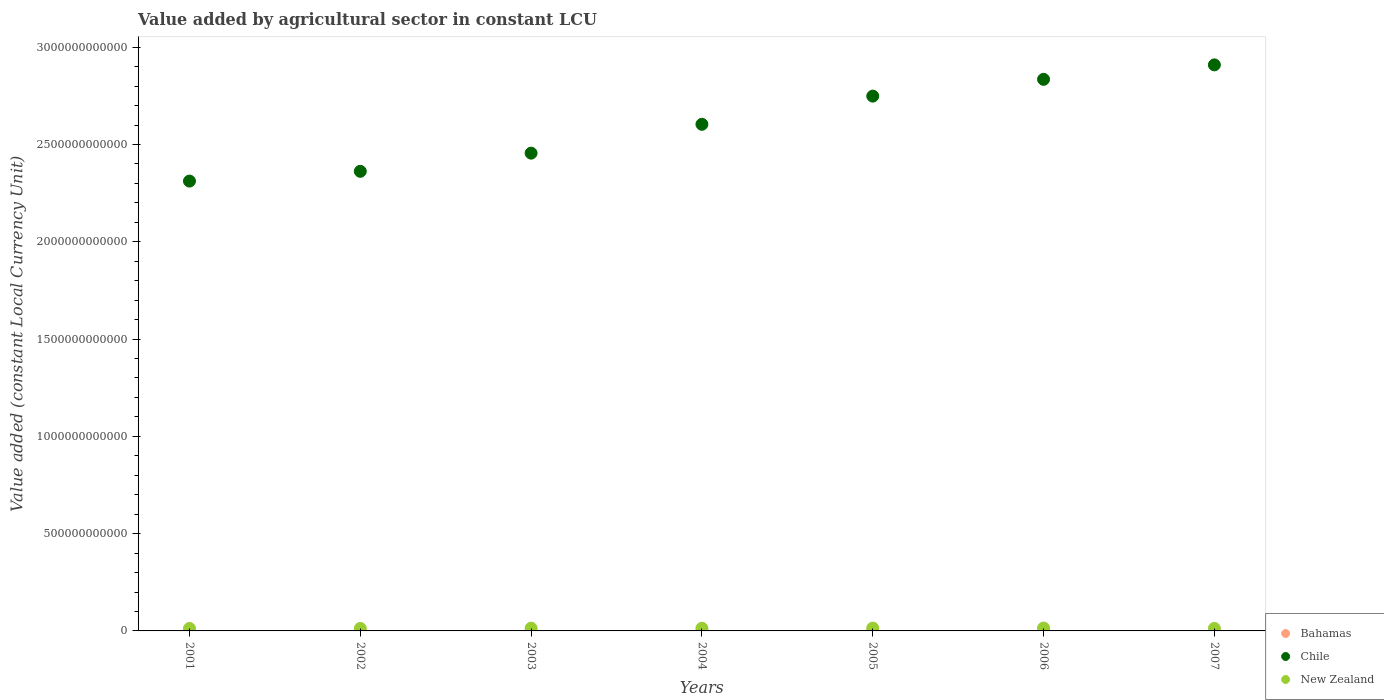Is the number of dotlines equal to the number of legend labels?
Keep it short and to the point. Yes. What is the value added by agricultural sector in New Zealand in 2003?
Offer a very short reply. 1.43e+1. Across all years, what is the maximum value added by agricultural sector in Bahamas?
Your answer should be very brief. 2.34e+08. Across all years, what is the minimum value added by agricultural sector in Chile?
Your answer should be compact. 2.31e+12. What is the total value added by agricultural sector in Bahamas in the graph?
Give a very brief answer. 1.40e+09. What is the difference between the value added by agricultural sector in New Zealand in 2002 and that in 2005?
Offer a terse response. -1.72e+09. What is the difference between the value added by agricultural sector in Bahamas in 2003 and the value added by agricultural sector in New Zealand in 2001?
Offer a very short reply. -1.27e+1. What is the average value added by agricultural sector in New Zealand per year?
Make the answer very short. 1.37e+1. In the year 2007, what is the difference between the value added by agricultural sector in New Zealand and value added by agricultural sector in Chile?
Offer a very short reply. -2.90e+12. In how many years, is the value added by agricultural sector in Chile greater than 600000000000 LCU?
Give a very brief answer. 7. What is the ratio of the value added by agricultural sector in Chile in 2003 to that in 2005?
Your answer should be compact. 0.89. Is the difference between the value added by agricultural sector in New Zealand in 2004 and 2005 greater than the difference between the value added by agricultural sector in Chile in 2004 and 2005?
Your answer should be very brief. Yes. What is the difference between the highest and the second highest value added by agricultural sector in Chile?
Offer a very short reply. 7.42e+1. What is the difference between the highest and the lowest value added by agricultural sector in Chile?
Make the answer very short. 5.97e+11. Is the sum of the value added by agricultural sector in Chile in 2003 and 2004 greater than the maximum value added by agricultural sector in New Zealand across all years?
Ensure brevity in your answer.  Yes. Is it the case that in every year, the sum of the value added by agricultural sector in Bahamas and value added by agricultural sector in New Zealand  is greater than the value added by agricultural sector in Chile?
Your answer should be very brief. No. Does the value added by agricultural sector in Bahamas monotonically increase over the years?
Your response must be concise. No. How many dotlines are there?
Provide a short and direct response. 3. What is the difference between two consecutive major ticks on the Y-axis?
Provide a succinct answer. 5.00e+11. Does the graph contain any zero values?
Your answer should be very brief. No. Does the graph contain grids?
Make the answer very short. No. How many legend labels are there?
Provide a succinct answer. 3. How are the legend labels stacked?
Ensure brevity in your answer.  Vertical. What is the title of the graph?
Your response must be concise. Value added by agricultural sector in constant LCU. What is the label or title of the X-axis?
Offer a terse response. Years. What is the label or title of the Y-axis?
Ensure brevity in your answer.  Value added (constant Local Currency Unit). What is the Value added (constant Local Currency Unit) of Bahamas in 2001?
Give a very brief answer. 1.89e+08. What is the Value added (constant Local Currency Unit) of Chile in 2001?
Provide a short and direct response. 2.31e+12. What is the Value added (constant Local Currency Unit) in New Zealand in 2001?
Your response must be concise. 1.29e+1. What is the Value added (constant Local Currency Unit) in Bahamas in 2002?
Your answer should be compact. 2.15e+08. What is the Value added (constant Local Currency Unit) of Chile in 2002?
Your answer should be compact. 2.36e+12. What is the Value added (constant Local Currency Unit) of New Zealand in 2002?
Your answer should be compact. 1.28e+1. What is the Value added (constant Local Currency Unit) of Bahamas in 2003?
Give a very brief answer. 2.34e+08. What is the Value added (constant Local Currency Unit) in Chile in 2003?
Your response must be concise. 2.46e+12. What is the Value added (constant Local Currency Unit) of New Zealand in 2003?
Provide a succinct answer. 1.43e+1. What is the Value added (constant Local Currency Unit) in Bahamas in 2004?
Give a very brief answer. 2.18e+08. What is the Value added (constant Local Currency Unit) of Chile in 2004?
Your answer should be compact. 2.60e+12. What is the Value added (constant Local Currency Unit) of New Zealand in 2004?
Your response must be concise. 1.38e+1. What is the Value added (constant Local Currency Unit) of Bahamas in 2005?
Make the answer very short. 1.97e+08. What is the Value added (constant Local Currency Unit) in Chile in 2005?
Your answer should be very brief. 2.75e+12. What is the Value added (constant Local Currency Unit) in New Zealand in 2005?
Provide a short and direct response. 1.46e+1. What is the Value added (constant Local Currency Unit) in Bahamas in 2006?
Provide a succinct answer. 1.80e+08. What is the Value added (constant Local Currency Unit) in Chile in 2006?
Offer a terse response. 2.83e+12. What is the Value added (constant Local Currency Unit) in New Zealand in 2006?
Provide a succinct answer. 1.48e+1. What is the Value added (constant Local Currency Unit) in Bahamas in 2007?
Your response must be concise. 1.67e+08. What is the Value added (constant Local Currency Unit) in Chile in 2007?
Your answer should be very brief. 2.91e+12. What is the Value added (constant Local Currency Unit) of New Zealand in 2007?
Provide a succinct answer. 1.30e+1. Across all years, what is the maximum Value added (constant Local Currency Unit) in Bahamas?
Offer a very short reply. 2.34e+08. Across all years, what is the maximum Value added (constant Local Currency Unit) of Chile?
Offer a terse response. 2.91e+12. Across all years, what is the maximum Value added (constant Local Currency Unit) in New Zealand?
Offer a terse response. 1.48e+1. Across all years, what is the minimum Value added (constant Local Currency Unit) in Bahamas?
Provide a succinct answer. 1.67e+08. Across all years, what is the minimum Value added (constant Local Currency Unit) in Chile?
Provide a succinct answer. 2.31e+12. Across all years, what is the minimum Value added (constant Local Currency Unit) in New Zealand?
Provide a succinct answer. 1.28e+1. What is the total Value added (constant Local Currency Unit) in Bahamas in the graph?
Give a very brief answer. 1.40e+09. What is the total Value added (constant Local Currency Unit) in Chile in the graph?
Your answer should be very brief. 1.82e+13. What is the total Value added (constant Local Currency Unit) of New Zealand in the graph?
Provide a succinct answer. 9.61e+1. What is the difference between the Value added (constant Local Currency Unit) in Bahamas in 2001 and that in 2002?
Keep it short and to the point. -2.56e+07. What is the difference between the Value added (constant Local Currency Unit) in Chile in 2001 and that in 2002?
Your answer should be very brief. -5.01e+1. What is the difference between the Value added (constant Local Currency Unit) of New Zealand in 2001 and that in 2002?
Make the answer very short. 7.30e+07. What is the difference between the Value added (constant Local Currency Unit) of Bahamas in 2001 and that in 2003?
Your answer should be compact. -4.52e+07. What is the difference between the Value added (constant Local Currency Unit) of Chile in 2001 and that in 2003?
Make the answer very short. -1.44e+11. What is the difference between the Value added (constant Local Currency Unit) of New Zealand in 2001 and that in 2003?
Ensure brevity in your answer.  -1.37e+09. What is the difference between the Value added (constant Local Currency Unit) in Bahamas in 2001 and that in 2004?
Provide a short and direct response. -2.93e+07. What is the difference between the Value added (constant Local Currency Unit) in Chile in 2001 and that in 2004?
Your answer should be compact. -2.92e+11. What is the difference between the Value added (constant Local Currency Unit) of New Zealand in 2001 and that in 2004?
Provide a succinct answer. -9.27e+08. What is the difference between the Value added (constant Local Currency Unit) in Bahamas in 2001 and that in 2005?
Offer a terse response. -7.60e+06. What is the difference between the Value added (constant Local Currency Unit) of Chile in 2001 and that in 2005?
Provide a short and direct response. -4.37e+11. What is the difference between the Value added (constant Local Currency Unit) of New Zealand in 2001 and that in 2005?
Your response must be concise. -1.65e+09. What is the difference between the Value added (constant Local Currency Unit) in Bahamas in 2001 and that in 2006?
Ensure brevity in your answer.  8.47e+06. What is the difference between the Value added (constant Local Currency Unit) in Chile in 2001 and that in 2006?
Your response must be concise. -5.23e+11. What is the difference between the Value added (constant Local Currency Unit) in New Zealand in 2001 and that in 2006?
Offer a very short reply. -1.86e+09. What is the difference between the Value added (constant Local Currency Unit) of Bahamas in 2001 and that in 2007?
Your answer should be very brief. 2.17e+07. What is the difference between the Value added (constant Local Currency Unit) of Chile in 2001 and that in 2007?
Provide a succinct answer. -5.97e+11. What is the difference between the Value added (constant Local Currency Unit) in New Zealand in 2001 and that in 2007?
Give a very brief answer. -4.23e+07. What is the difference between the Value added (constant Local Currency Unit) in Bahamas in 2002 and that in 2003?
Provide a succinct answer. -1.96e+07. What is the difference between the Value added (constant Local Currency Unit) in Chile in 2002 and that in 2003?
Offer a terse response. -9.35e+1. What is the difference between the Value added (constant Local Currency Unit) in New Zealand in 2002 and that in 2003?
Give a very brief answer. -1.44e+09. What is the difference between the Value added (constant Local Currency Unit) in Bahamas in 2002 and that in 2004?
Your response must be concise. -3.66e+06. What is the difference between the Value added (constant Local Currency Unit) of Chile in 2002 and that in 2004?
Offer a terse response. -2.42e+11. What is the difference between the Value added (constant Local Currency Unit) in New Zealand in 2002 and that in 2004?
Your response must be concise. -1.00e+09. What is the difference between the Value added (constant Local Currency Unit) of Bahamas in 2002 and that in 2005?
Offer a very short reply. 1.80e+07. What is the difference between the Value added (constant Local Currency Unit) of Chile in 2002 and that in 2005?
Give a very brief answer. -3.87e+11. What is the difference between the Value added (constant Local Currency Unit) of New Zealand in 2002 and that in 2005?
Keep it short and to the point. -1.72e+09. What is the difference between the Value added (constant Local Currency Unit) of Bahamas in 2002 and that in 2006?
Ensure brevity in your answer.  3.41e+07. What is the difference between the Value added (constant Local Currency Unit) of Chile in 2002 and that in 2006?
Provide a succinct answer. -4.73e+11. What is the difference between the Value added (constant Local Currency Unit) of New Zealand in 2002 and that in 2006?
Offer a very short reply. -1.93e+09. What is the difference between the Value added (constant Local Currency Unit) in Bahamas in 2002 and that in 2007?
Keep it short and to the point. 4.73e+07. What is the difference between the Value added (constant Local Currency Unit) in Chile in 2002 and that in 2007?
Your response must be concise. -5.47e+11. What is the difference between the Value added (constant Local Currency Unit) in New Zealand in 2002 and that in 2007?
Your answer should be very brief. -1.15e+08. What is the difference between the Value added (constant Local Currency Unit) of Bahamas in 2003 and that in 2004?
Provide a succinct answer. 1.60e+07. What is the difference between the Value added (constant Local Currency Unit) of Chile in 2003 and that in 2004?
Provide a succinct answer. -1.48e+11. What is the difference between the Value added (constant Local Currency Unit) in New Zealand in 2003 and that in 2004?
Give a very brief answer. 4.39e+08. What is the difference between the Value added (constant Local Currency Unit) of Bahamas in 2003 and that in 2005?
Provide a succinct answer. 3.76e+07. What is the difference between the Value added (constant Local Currency Unit) of Chile in 2003 and that in 2005?
Make the answer very short. -2.93e+11. What is the difference between the Value added (constant Local Currency Unit) of New Zealand in 2003 and that in 2005?
Provide a short and direct response. -2.79e+08. What is the difference between the Value added (constant Local Currency Unit) of Bahamas in 2003 and that in 2006?
Provide a short and direct response. 5.37e+07. What is the difference between the Value added (constant Local Currency Unit) of Chile in 2003 and that in 2006?
Ensure brevity in your answer.  -3.79e+11. What is the difference between the Value added (constant Local Currency Unit) in New Zealand in 2003 and that in 2006?
Your response must be concise. -4.94e+08. What is the difference between the Value added (constant Local Currency Unit) in Bahamas in 2003 and that in 2007?
Make the answer very short. 6.69e+07. What is the difference between the Value added (constant Local Currency Unit) of Chile in 2003 and that in 2007?
Offer a terse response. -4.54e+11. What is the difference between the Value added (constant Local Currency Unit) in New Zealand in 2003 and that in 2007?
Ensure brevity in your answer.  1.32e+09. What is the difference between the Value added (constant Local Currency Unit) of Bahamas in 2004 and that in 2005?
Your answer should be compact. 2.17e+07. What is the difference between the Value added (constant Local Currency Unit) of Chile in 2004 and that in 2005?
Your answer should be compact. -1.45e+11. What is the difference between the Value added (constant Local Currency Unit) of New Zealand in 2004 and that in 2005?
Give a very brief answer. -7.18e+08. What is the difference between the Value added (constant Local Currency Unit) of Bahamas in 2004 and that in 2006?
Keep it short and to the point. 3.77e+07. What is the difference between the Value added (constant Local Currency Unit) of Chile in 2004 and that in 2006?
Provide a short and direct response. -2.31e+11. What is the difference between the Value added (constant Local Currency Unit) in New Zealand in 2004 and that in 2006?
Your answer should be very brief. -9.34e+08. What is the difference between the Value added (constant Local Currency Unit) of Bahamas in 2004 and that in 2007?
Give a very brief answer. 5.10e+07. What is the difference between the Value added (constant Local Currency Unit) of Chile in 2004 and that in 2007?
Your response must be concise. -3.05e+11. What is the difference between the Value added (constant Local Currency Unit) of New Zealand in 2004 and that in 2007?
Your answer should be very brief. 8.85e+08. What is the difference between the Value added (constant Local Currency Unit) in Bahamas in 2005 and that in 2006?
Offer a very short reply. 1.61e+07. What is the difference between the Value added (constant Local Currency Unit) in Chile in 2005 and that in 2006?
Your answer should be very brief. -8.64e+1. What is the difference between the Value added (constant Local Currency Unit) of New Zealand in 2005 and that in 2006?
Your response must be concise. -2.15e+08. What is the difference between the Value added (constant Local Currency Unit) in Bahamas in 2005 and that in 2007?
Ensure brevity in your answer.  2.93e+07. What is the difference between the Value added (constant Local Currency Unit) of Chile in 2005 and that in 2007?
Offer a very short reply. -1.61e+11. What is the difference between the Value added (constant Local Currency Unit) in New Zealand in 2005 and that in 2007?
Your response must be concise. 1.60e+09. What is the difference between the Value added (constant Local Currency Unit) in Bahamas in 2006 and that in 2007?
Your answer should be compact. 1.32e+07. What is the difference between the Value added (constant Local Currency Unit) of Chile in 2006 and that in 2007?
Your answer should be very brief. -7.42e+1. What is the difference between the Value added (constant Local Currency Unit) in New Zealand in 2006 and that in 2007?
Offer a terse response. 1.82e+09. What is the difference between the Value added (constant Local Currency Unit) of Bahamas in 2001 and the Value added (constant Local Currency Unit) of Chile in 2002?
Your response must be concise. -2.36e+12. What is the difference between the Value added (constant Local Currency Unit) in Bahamas in 2001 and the Value added (constant Local Currency Unit) in New Zealand in 2002?
Give a very brief answer. -1.26e+1. What is the difference between the Value added (constant Local Currency Unit) of Chile in 2001 and the Value added (constant Local Currency Unit) of New Zealand in 2002?
Ensure brevity in your answer.  2.30e+12. What is the difference between the Value added (constant Local Currency Unit) in Bahamas in 2001 and the Value added (constant Local Currency Unit) in Chile in 2003?
Provide a succinct answer. -2.46e+12. What is the difference between the Value added (constant Local Currency Unit) of Bahamas in 2001 and the Value added (constant Local Currency Unit) of New Zealand in 2003?
Provide a short and direct response. -1.41e+1. What is the difference between the Value added (constant Local Currency Unit) in Chile in 2001 and the Value added (constant Local Currency Unit) in New Zealand in 2003?
Give a very brief answer. 2.30e+12. What is the difference between the Value added (constant Local Currency Unit) in Bahamas in 2001 and the Value added (constant Local Currency Unit) in Chile in 2004?
Offer a very short reply. -2.60e+12. What is the difference between the Value added (constant Local Currency Unit) in Bahamas in 2001 and the Value added (constant Local Currency Unit) in New Zealand in 2004?
Your answer should be compact. -1.36e+1. What is the difference between the Value added (constant Local Currency Unit) in Chile in 2001 and the Value added (constant Local Currency Unit) in New Zealand in 2004?
Provide a short and direct response. 2.30e+12. What is the difference between the Value added (constant Local Currency Unit) of Bahamas in 2001 and the Value added (constant Local Currency Unit) of Chile in 2005?
Your response must be concise. -2.75e+12. What is the difference between the Value added (constant Local Currency Unit) of Bahamas in 2001 and the Value added (constant Local Currency Unit) of New Zealand in 2005?
Ensure brevity in your answer.  -1.44e+1. What is the difference between the Value added (constant Local Currency Unit) in Chile in 2001 and the Value added (constant Local Currency Unit) in New Zealand in 2005?
Offer a terse response. 2.30e+12. What is the difference between the Value added (constant Local Currency Unit) of Bahamas in 2001 and the Value added (constant Local Currency Unit) of Chile in 2006?
Your answer should be compact. -2.83e+12. What is the difference between the Value added (constant Local Currency Unit) of Bahamas in 2001 and the Value added (constant Local Currency Unit) of New Zealand in 2006?
Your response must be concise. -1.46e+1. What is the difference between the Value added (constant Local Currency Unit) in Chile in 2001 and the Value added (constant Local Currency Unit) in New Zealand in 2006?
Give a very brief answer. 2.30e+12. What is the difference between the Value added (constant Local Currency Unit) of Bahamas in 2001 and the Value added (constant Local Currency Unit) of Chile in 2007?
Make the answer very short. -2.91e+12. What is the difference between the Value added (constant Local Currency Unit) in Bahamas in 2001 and the Value added (constant Local Currency Unit) in New Zealand in 2007?
Make the answer very short. -1.28e+1. What is the difference between the Value added (constant Local Currency Unit) in Chile in 2001 and the Value added (constant Local Currency Unit) in New Zealand in 2007?
Provide a succinct answer. 2.30e+12. What is the difference between the Value added (constant Local Currency Unit) in Bahamas in 2002 and the Value added (constant Local Currency Unit) in Chile in 2003?
Provide a short and direct response. -2.46e+12. What is the difference between the Value added (constant Local Currency Unit) of Bahamas in 2002 and the Value added (constant Local Currency Unit) of New Zealand in 2003?
Give a very brief answer. -1.41e+1. What is the difference between the Value added (constant Local Currency Unit) in Chile in 2002 and the Value added (constant Local Currency Unit) in New Zealand in 2003?
Your answer should be very brief. 2.35e+12. What is the difference between the Value added (constant Local Currency Unit) in Bahamas in 2002 and the Value added (constant Local Currency Unit) in Chile in 2004?
Provide a succinct answer. -2.60e+12. What is the difference between the Value added (constant Local Currency Unit) in Bahamas in 2002 and the Value added (constant Local Currency Unit) in New Zealand in 2004?
Your answer should be very brief. -1.36e+1. What is the difference between the Value added (constant Local Currency Unit) of Chile in 2002 and the Value added (constant Local Currency Unit) of New Zealand in 2004?
Offer a terse response. 2.35e+12. What is the difference between the Value added (constant Local Currency Unit) of Bahamas in 2002 and the Value added (constant Local Currency Unit) of Chile in 2005?
Your answer should be very brief. -2.75e+12. What is the difference between the Value added (constant Local Currency Unit) in Bahamas in 2002 and the Value added (constant Local Currency Unit) in New Zealand in 2005?
Your answer should be very brief. -1.43e+1. What is the difference between the Value added (constant Local Currency Unit) of Chile in 2002 and the Value added (constant Local Currency Unit) of New Zealand in 2005?
Provide a short and direct response. 2.35e+12. What is the difference between the Value added (constant Local Currency Unit) of Bahamas in 2002 and the Value added (constant Local Currency Unit) of Chile in 2006?
Your answer should be compact. -2.83e+12. What is the difference between the Value added (constant Local Currency Unit) in Bahamas in 2002 and the Value added (constant Local Currency Unit) in New Zealand in 2006?
Your answer should be very brief. -1.46e+1. What is the difference between the Value added (constant Local Currency Unit) of Chile in 2002 and the Value added (constant Local Currency Unit) of New Zealand in 2006?
Offer a terse response. 2.35e+12. What is the difference between the Value added (constant Local Currency Unit) in Bahamas in 2002 and the Value added (constant Local Currency Unit) in Chile in 2007?
Give a very brief answer. -2.91e+12. What is the difference between the Value added (constant Local Currency Unit) in Bahamas in 2002 and the Value added (constant Local Currency Unit) in New Zealand in 2007?
Offer a very short reply. -1.27e+1. What is the difference between the Value added (constant Local Currency Unit) of Chile in 2002 and the Value added (constant Local Currency Unit) of New Zealand in 2007?
Offer a terse response. 2.35e+12. What is the difference between the Value added (constant Local Currency Unit) of Bahamas in 2003 and the Value added (constant Local Currency Unit) of Chile in 2004?
Your answer should be compact. -2.60e+12. What is the difference between the Value added (constant Local Currency Unit) in Bahamas in 2003 and the Value added (constant Local Currency Unit) in New Zealand in 2004?
Your response must be concise. -1.36e+1. What is the difference between the Value added (constant Local Currency Unit) in Chile in 2003 and the Value added (constant Local Currency Unit) in New Zealand in 2004?
Ensure brevity in your answer.  2.44e+12. What is the difference between the Value added (constant Local Currency Unit) in Bahamas in 2003 and the Value added (constant Local Currency Unit) in Chile in 2005?
Your answer should be compact. -2.75e+12. What is the difference between the Value added (constant Local Currency Unit) in Bahamas in 2003 and the Value added (constant Local Currency Unit) in New Zealand in 2005?
Provide a succinct answer. -1.43e+1. What is the difference between the Value added (constant Local Currency Unit) in Chile in 2003 and the Value added (constant Local Currency Unit) in New Zealand in 2005?
Give a very brief answer. 2.44e+12. What is the difference between the Value added (constant Local Currency Unit) in Bahamas in 2003 and the Value added (constant Local Currency Unit) in Chile in 2006?
Provide a short and direct response. -2.83e+12. What is the difference between the Value added (constant Local Currency Unit) in Bahamas in 2003 and the Value added (constant Local Currency Unit) in New Zealand in 2006?
Offer a very short reply. -1.45e+1. What is the difference between the Value added (constant Local Currency Unit) of Chile in 2003 and the Value added (constant Local Currency Unit) of New Zealand in 2006?
Offer a terse response. 2.44e+12. What is the difference between the Value added (constant Local Currency Unit) in Bahamas in 2003 and the Value added (constant Local Currency Unit) in Chile in 2007?
Your answer should be very brief. -2.91e+12. What is the difference between the Value added (constant Local Currency Unit) of Bahamas in 2003 and the Value added (constant Local Currency Unit) of New Zealand in 2007?
Your answer should be compact. -1.27e+1. What is the difference between the Value added (constant Local Currency Unit) of Chile in 2003 and the Value added (constant Local Currency Unit) of New Zealand in 2007?
Your answer should be compact. 2.44e+12. What is the difference between the Value added (constant Local Currency Unit) of Bahamas in 2004 and the Value added (constant Local Currency Unit) of Chile in 2005?
Provide a succinct answer. -2.75e+12. What is the difference between the Value added (constant Local Currency Unit) in Bahamas in 2004 and the Value added (constant Local Currency Unit) in New Zealand in 2005?
Offer a terse response. -1.43e+1. What is the difference between the Value added (constant Local Currency Unit) in Chile in 2004 and the Value added (constant Local Currency Unit) in New Zealand in 2005?
Keep it short and to the point. 2.59e+12. What is the difference between the Value added (constant Local Currency Unit) in Bahamas in 2004 and the Value added (constant Local Currency Unit) in Chile in 2006?
Ensure brevity in your answer.  -2.83e+12. What is the difference between the Value added (constant Local Currency Unit) in Bahamas in 2004 and the Value added (constant Local Currency Unit) in New Zealand in 2006?
Your answer should be compact. -1.46e+1. What is the difference between the Value added (constant Local Currency Unit) of Chile in 2004 and the Value added (constant Local Currency Unit) of New Zealand in 2006?
Offer a very short reply. 2.59e+12. What is the difference between the Value added (constant Local Currency Unit) of Bahamas in 2004 and the Value added (constant Local Currency Unit) of Chile in 2007?
Your response must be concise. -2.91e+12. What is the difference between the Value added (constant Local Currency Unit) of Bahamas in 2004 and the Value added (constant Local Currency Unit) of New Zealand in 2007?
Offer a terse response. -1.27e+1. What is the difference between the Value added (constant Local Currency Unit) in Chile in 2004 and the Value added (constant Local Currency Unit) in New Zealand in 2007?
Provide a short and direct response. 2.59e+12. What is the difference between the Value added (constant Local Currency Unit) of Bahamas in 2005 and the Value added (constant Local Currency Unit) of Chile in 2006?
Ensure brevity in your answer.  -2.83e+12. What is the difference between the Value added (constant Local Currency Unit) in Bahamas in 2005 and the Value added (constant Local Currency Unit) in New Zealand in 2006?
Your response must be concise. -1.46e+1. What is the difference between the Value added (constant Local Currency Unit) of Chile in 2005 and the Value added (constant Local Currency Unit) of New Zealand in 2006?
Keep it short and to the point. 2.73e+12. What is the difference between the Value added (constant Local Currency Unit) in Bahamas in 2005 and the Value added (constant Local Currency Unit) in Chile in 2007?
Keep it short and to the point. -2.91e+12. What is the difference between the Value added (constant Local Currency Unit) in Bahamas in 2005 and the Value added (constant Local Currency Unit) in New Zealand in 2007?
Give a very brief answer. -1.28e+1. What is the difference between the Value added (constant Local Currency Unit) in Chile in 2005 and the Value added (constant Local Currency Unit) in New Zealand in 2007?
Keep it short and to the point. 2.74e+12. What is the difference between the Value added (constant Local Currency Unit) in Bahamas in 2006 and the Value added (constant Local Currency Unit) in Chile in 2007?
Offer a very short reply. -2.91e+12. What is the difference between the Value added (constant Local Currency Unit) in Bahamas in 2006 and the Value added (constant Local Currency Unit) in New Zealand in 2007?
Offer a very short reply. -1.28e+1. What is the difference between the Value added (constant Local Currency Unit) in Chile in 2006 and the Value added (constant Local Currency Unit) in New Zealand in 2007?
Provide a succinct answer. 2.82e+12. What is the average Value added (constant Local Currency Unit) in Bahamas per year?
Your response must be concise. 2.00e+08. What is the average Value added (constant Local Currency Unit) in Chile per year?
Make the answer very short. 2.60e+12. What is the average Value added (constant Local Currency Unit) of New Zealand per year?
Make the answer very short. 1.37e+1. In the year 2001, what is the difference between the Value added (constant Local Currency Unit) in Bahamas and Value added (constant Local Currency Unit) in Chile?
Offer a terse response. -2.31e+12. In the year 2001, what is the difference between the Value added (constant Local Currency Unit) in Bahamas and Value added (constant Local Currency Unit) in New Zealand?
Your answer should be very brief. -1.27e+1. In the year 2001, what is the difference between the Value added (constant Local Currency Unit) of Chile and Value added (constant Local Currency Unit) of New Zealand?
Ensure brevity in your answer.  2.30e+12. In the year 2002, what is the difference between the Value added (constant Local Currency Unit) of Bahamas and Value added (constant Local Currency Unit) of Chile?
Offer a very short reply. -2.36e+12. In the year 2002, what is the difference between the Value added (constant Local Currency Unit) in Bahamas and Value added (constant Local Currency Unit) in New Zealand?
Offer a very short reply. -1.26e+1. In the year 2002, what is the difference between the Value added (constant Local Currency Unit) in Chile and Value added (constant Local Currency Unit) in New Zealand?
Provide a short and direct response. 2.35e+12. In the year 2003, what is the difference between the Value added (constant Local Currency Unit) of Bahamas and Value added (constant Local Currency Unit) of Chile?
Provide a short and direct response. -2.46e+12. In the year 2003, what is the difference between the Value added (constant Local Currency Unit) in Bahamas and Value added (constant Local Currency Unit) in New Zealand?
Ensure brevity in your answer.  -1.40e+1. In the year 2003, what is the difference between the Value added (constant Local Currency Unit) of Chile and Value added (constant Local Currency Unit) of New Zealand?
Ensure brevity in your answer.  2.44e+12. In the year 2004, what is the difference between the Value added (constant Local Currency Unit) in Bahamas and Value added (constant Local Currency Unit) in Chile?
Your response must be concise. -2.60e+12. In the year 2004, what is the difference between the Value added (constant Local Currency Unit) of Bahamas and Value added (constant Local Currency Unit) of New Zealand?
Offer a terse response. -1.36e+1. In the year 2004, what is the difference between the Value added (constant Local Currency Unit) of Chile and Value added (constant Local Currency Unit) of New Zealand?
Give a very brief answer. 2.59e+12. In the year 2005, what is the difference between the Value added (constant Local Currency Unit) of Bahamas and Value added (constant Local Currency Unit) of Chile?
Make the answer very short. -2.75e+12. In the year 2005, what is the difference between the Value added (constant Local Currency Unit) of Bahamas and Value added (constant Local Currency Unit) of New Zealand?
Make the answer very short. -1.44e+1. In the year 2005, what is the difference between the Value added (constant Local Currency Unit) in Chile and Value added (constant Local Currency Unit) in New Zealand?
Provide a short and direct response. 2.73e+12. In the year 2006, what is the difference between the Value added (constant Local Currency Unit) in Bahamas and Value added (constant Local Currency Unit) in Chile?
Ensure brevity in your answer.  -2.83e+12. In the year 2006, what is the difference between the Value added (constant Local Currency Unit) in Bahamas and Value added (constant Local Currency Unit) in New Zealand?
Ensure brevity in your answer.  -1.46e+1. In the year 2006, what is the difference between the Value added (constant Local Currency Unit) in Chile and Value added (constant Local Currency Unit) in New Zealand?
Your response must be concise. 2.82e+12. In the year 2007, what is the difference between the Value added (constant Local Currency Unit) in Bahamas and Value added (constant Local Currency Unit) in Chile?
Your answer should be compact. -2.91e+12. In the year 2007, what is the difference between the Value added (constant Local Currency Unit) in Bahamas and Value added (constant Local Currency Unit) in New Zealand?
Keep it short and to the point. -1.28e+1. In the year 2007, what is the difference between the Value added (constant Local Currency Unit) in Chile and Value added (constant Local Currency Unit) in New Zealand?
Ensure brevity in your answer.  2.90e+12. What is the ratio of the Value added (constant Local Currency Unit) of Bahamas in 2001 to that in 2002?
Provide a succinct answer. 0.88. What is the ratio of the Value added (constant Local Currency Unit) of Chile in 2001 to that in 2002?
Offer a very short reply. 0.98. What is the ratio of the Value added (constant Local Currency Unit) in Bahamas in 2001 to that in 2003?
Ensure brevity in your answer.  0.81. What is the ratio of the Value added (constant Local Currency Unit) in Chile in 2001 to that in 2003?
Offer a very short reply. 0.94. What is the ratio of the Value added (constant Local Currency Unit) in New Zealand in 2001 to that in 2003?
Keep it short and to the point. 0.9. What is the ratio of the Value added (constant Local Currency Unit) of Bahamas in 2001 to that in 2004?
Offer a very short reply. 0.87. What is the ratio of the Value added (constant Local Currency Unit) in Chile in 2001 to that in 2004?
Offer a terse response. 0.89. What is the ratio of the Value added (constant Local Currency Unit) in New Zealand in 2001 to that in 2004?
Your answer should be very brief. 0.93. What is the ratio of the Value added (constant Local Currency Unit) in Bahamas in 2001 to that in 2005?
Offer a very short reply. 0.96. What is the ratio of the Value added (constant Local Currency Unit) of Chile in 2001 to that in 2005?
Your answer should be very brief. 0.84. What is the ratio of the Value added (constant Local Currency Unit) of New Zealand in 2001 to that in 2005?
Offer a terse response. 0.89. What is the ratio of the Value added (constant Local Currency Unit) of Bahamas in 2001 to that in 2006?
Offer a terse response. 1.05. What is the ratio of the Value added (constant Local Currency Unit) of Chile in 2001 to that in 2006?
Provide a succinct answer. 0.82. What is the ratio of the Value added (constant Local Currency Unit) of New Zealand in 2001 to that in 2006?
Give a very brief answer. 0.87. What is the ratio of the Value added (constant Local Currency Unit) in Bahamas in 2001 to that in 2007?
Your answer should be very brief. 1.13. What is the ratio of the Value added (constant Local Currency Unit) of Chile in 2001 to that in 2007?
Provide a succinct answer. 0.79. What is the ratio of the Value added (constant Local Currency Unit) in New Zealand in 2001 to that in 2007?
Ensure brevity in your answer.  1. What is the ratio of the Value added (constant Local Currency Unit) of Bahamas in 2002 to that in 2003?
Offer a very short reply. 0.92. What is the ratio of the Value added (constant Local Currency Unit) of Chile in 2002 to that in 2003?
Make the answer very short. 0.96. What is the ratio of the Value added (constant Local Currency Unit) in New Zealand in 2002 to that in 2003?
Offer a terse response. 0.9. What is the ratio of the Value added (constant Local Currency Unit) in Bahamas in 2002 to that in 2004?
Give a very brief answer. 0.98. What is the ratio of the Value added (constant Local Currency Unit) in Chile in 2002 to that in 2004?
Provide a succinct answer. 0.91. What is the ratio of the Value added (constant Local Currency Unit) in New Zealand in 2002 to that in 2004?
Provide a short and direct response. 0.93. What is the ratio of the Value added (constant Local Currency Unit) of Bahamas in 2002 to that in 2005?
Make the answer very short. 1.09. What is the ratio of the Value added (constant Local Currency Unit) of Chile in 2002 to that in 2005?
Offer a terse response. 0.86. What is the ratio of the Value added (constant Local Currency Unit) in New Zealand in 2002 to that in 2005?
Provide a succinct answer. 0.88. What is the ratio of the Value added (constant Local Currency Unit) in Bahamas in 2002 to that in 2006?
Provide a short and direct response. 1.19. What is the ratio of the Value added (constant Local Currency Unit) of Chile in 2002 to that in 2006?
Your answer should be compact. 0.83. What is the ratio of the Value added (constant Local Currency Unit) in New Zealand in 2002 to that in 2006?
Keep it short and to the point. 0.87. What is the ratio of the Value added (constant Local Currency Unit) in Bahamas in 2002 to that in 2007?
Keep it short and to the point. 1.28. What is the ratio of the Value added (constant Local Currency Unit) in Chile in 2002 to that in 2007?
Make the answer very short. 0.81. What is the ratio of the Value added (constant Local Currency Unit) of New Zealand in 2002 to that in 2007?
Your answer should be compact. 0.99. What is the ratio of the Value added (constant Local Currency Unit) in Bahamas in 2003 to that in 2004?
Provide a succinct answer. 1.07. What is the ratio of the Value added (constant Local Currency Unit) of Chile in 2003 to that in 2004?
Ensure brevity in your answer.  0.94. What is the ratio of the Value added (constant Local Currency Unit) in New Zealand in 2003 to that in 2004?
Provide a short and direct response. 1.03. What is the ratio of the Value added (constant Local Currency Unit) of Bahamas in 2003 to that in 2005?
Provide a short and direct response. 1.19. What is the ratio of the Value added (constant Local Currency Unit) of Chile in 2003 to that in 2005?
Your answer should be compact. 0.89. What is the ratio of the Value added (constant Local Currency Unit) of New Zealand in 2003 to that in 2005?
Your response must be concise. 0.98. What is the ratio of the Value added (constant Local Currency Unit) in Bahamas in 2003 to that in 2006?
Your response must be concise. 1.3. What is the ratio of the Value added (constant Local Currency Unit) in Chile in 2003 to that in 2006?
Provide a short and direct response. 0.87. What is the ratio of the Value added (constant Local Currency Unit) of New Zealand in 2003 to that in 2006?
Provide a succinct answer. 0.97. What is the ratio of the Value added (constant Local Currency Unit) of Bahamas in 2003 to that in 2007?
Your response must be concise. 1.4. What is the ratio of the Value added (constant Local Currency Unit) of Chile in 2003 to that in 2007?
Your response must be concise. 0.84. What is the ratio of the Value added (constant Local Currency Unit) in New Zealand in 2003 to that in 2007?
Make the answer very short. 1.1. What is the ratio of the Value added (constant Local Currency Unit) in Bahamas in 2004 to that in 2005?
Your answer should be compact. 1.11. What is the ratio of the Value added (constant Local Currency Unit) in Chile in 2004 to that in 2005?
Provide a succinct answer. 0.95. What is the ratio of the Value added (constant Local Currency Unit) of New Zealand in 2004 to that in 2005?
Ensure brevity in your answer.  0.95. What is the ratio of the Value added (constant Local Currency Unit) of Bahamas in 2004 to that in 2006?
Provide a succinct answer. 1.21. What is the ratio of the Value added (constant Local Currency Unit) of Chile in 2004 to that in 2006?
Ensure brevity in your answer.  0.92. What is the ratio of the Value added (constant Local Currency Unit) of New Zealand in 2004 to that in 2006?
Your response must be concise. 0.94. What is the ratio of the Value added (constant Local Currency Unit) in Bahamas in 2004 to that in 2007?
Your answer should be compact. 1.3. What is the ratio of the Value added (constant Local Currency Unit) in Chile in 2004 to that in 2007?
Provide a succinct answer. 0.9. What is the ratio of the Value added (constant Local Currency Unit) of New Zealand in 2004 to that in 2007?
Your answer should be compact. 1.07. What is the ratio of the Value added (constant Local Currency Unit) in Bahamas in 2005 to that in 2006?
Make the answer very short. 1.09. What is the ratio of the Value added (constant Local Currency Unit) of Chile in 2005 to that in 2006?
Offer a terse response. 0.97. What is the ratio of the Value added (constant Local Currency Unit) of New Zealand in 2005 to that in 2006?
Ensure brevity in your answer.  0.99. What is the ratio of the Value added (constant Local Currency Unit) in Bahamas in 2005 to that in 2007?
Your answer should be compact. 1.18. What is the ratio of the Value added (constant Local Currency Unit) of Chile in 2005 to that in 2007?
Provide a short and direct response. 0.94. What is the ratio of the Value added (constant Local Currency Unit) in New Zealand in 2005 to that in 2007?
Make the answer very short. 1.12. What is the ratio of the Value added (constant Local Currency Unit) in Bahamas in 2006 to that in 2007?
Offer a terse response. 1.08. What is the ratio of the Value added (constant Local Currency Unit) in Chile in 2006 to that in 2007?
Offer a very short reply. 0.97. What is the ratio of the Value added (constant Local Currency Unit) in New Zealand in 2006 to that in 2007?
Offer a terse response. 1.14. What is the difference between the highest and the second highest Value added (constant Local Currency Unit) of Bahamas?
Your answer should be compact. 1.60e+07. What is the difference between the highest and the second highest Value added (constant Local Currency Unit) in Chile?
Offer a terse response. 7.42e+1. What is the difference between the highest and the second highest Value added (constant Local Currency Unit) of New Zealand?
Keep it short and to the point. 2.15e+08. What is the difference between the highest and the lowest Value added (constant Local Currency Unit) of Bahamas?
Offer a terse response. 6.69e+07. What is the difference between the highest and the lowest Value added (constant Local Currency Unit) of Chile?
Keep it short and to the point. 5.97e+11. What is the difference between the highest and the lowest Value added (constant Local Currency Unit) in New Zealand?
Offer a terse response. 1.93e+09. 